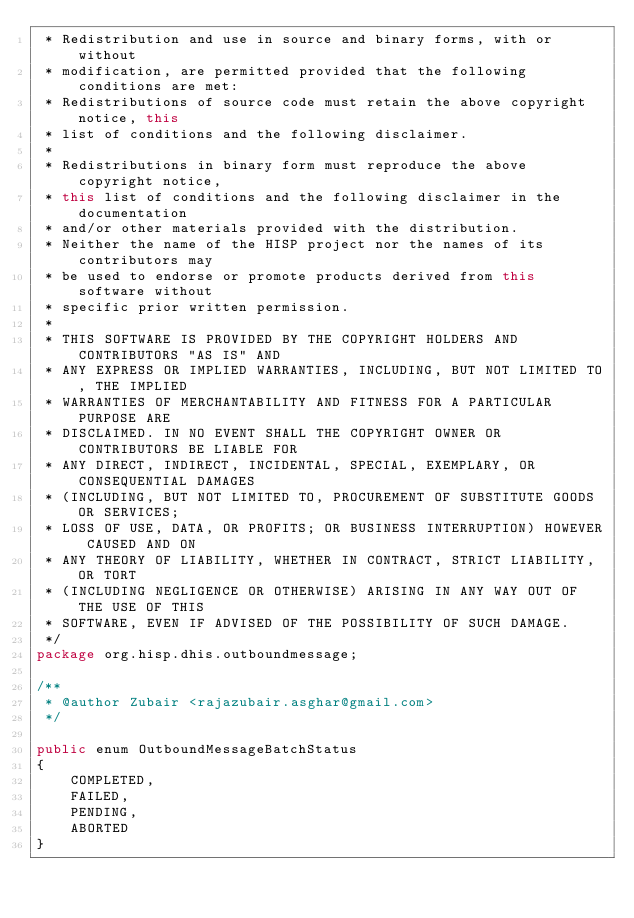<code> <loc_0><loc_0><loc_500><loc_500><_Java_> * Redistribution and use in source and binary forms, with or without
 * modification, are permitted provided that the following conditions are met:
 * Redistributions of source code must retain the above copyright notice, this
 * list of conditions and the following disclaimer.
 *
 * Redistributions in binary form must reproduce the above copyright notice,
 * this list of conditions and the following disclaimer in the documentation
 * and/or other materials provided with the distribution.
 * Neither the name of the HISP project nor the names of its contributors may
 * be used to endorse or promote products derived from this software without
 * specific prior written permission.
 *
 * THIS SOFTWARE IS PROVIDED BY THE COPYRIGHT HOLDERS AND CONTRIBUTORS "AS IS" AND
 * ANY EXPRESS OR IMPLIED WARRANTIES, INCLUDING, BUT NOT LIMITED TO, THE IMPLIED
 * WARRANTIES OF MERCHANTABILITY AND FITNESS FOR A PARTICULAR PURPOSE ARE
 * DISCLAIMED. IN NO EVENT SHALL THE COPYRIGHT OWNER OR CONTRIBUTORS BE LIABLE FOR
 * ANY DIRECT, INDIRECT, INCIDENTAL, SPECIAL, EXEMPLARY, OR CONSEQUENTIAL DAMAGES
 * (INCLUDING, BUT NOT LIMITED TO, PROCUREMENT OF SUBSTITUTE GOODS OR SERVICES;
 * LOSS OF USE, DATA, OR PROFITS; OR BUSINESS INTERRUPTION) HOWEVER CAUSED AND ON
 * ANY THEORY OF LIABILITY, WHETHER IN CONTRACT, STRICT LIABILITY, OR TORT
 * (INCLUDING NEGLIGENCE OR OTHERWISE) ARISING IN ANY WAY OUT OF THE USE OF THIS
 * SOFTWARE, EVEN IF ADVISED OF THE POSSIBILITY OF SUCH DAMAGE.
 */
package org.hisp.dhis.outboundmessage;

/**
 * @author Zubair <rajazubair.asghar@gmail.com>
 */

public enum OutboundMessageBatchStatus
{
    COMPLETED,
    FAILED,
    PENDING,
    ABORTED
}
</code> 